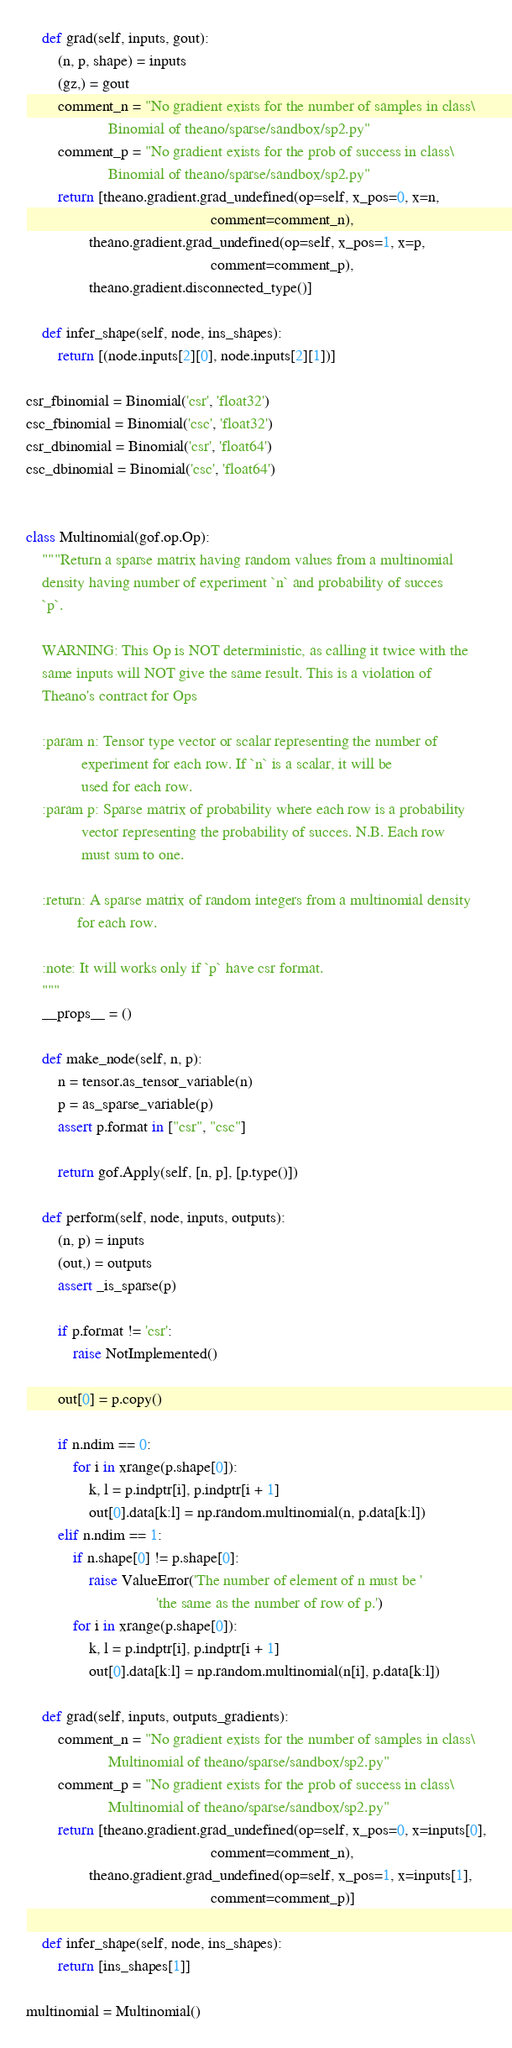Convert code to text. <code><loc_0><loc_0><loc_500><loc_500><_Python_>
    def grad(self, inputs, gout):
        (n, p, shape) = inputs
        (gz,) = gout
        comment_n = "No gradient exists for the number of samples in class\
                     Binomial of theano/sparse/sandbox/sp2.py"
        comment_p = "No gradient exists for the prob of success in class\
                     Binomial of theano/sparse/sandbox/sp2.py"
        return [theano.gradient.grad_undefined(op=self, x_pos=0, x=n,
                                               comment=comment_n),
                theano.gradient.grad_undefined(op=self, x_pos=1, x=p,
                                               comment=comment_p),
                theano.gradient.disconnected_type()]

    def infer_shape(self, node, ins_shapes):
        return [(node.inputs[2][0], node.inputs[2][1])]

csr_fbinomial = Binomial('csr', 'float32')
csc_fbinomial = Binomial('csc', 'float32')
csr_dbinomial = Binomial('csr', 'float64')
csc_dbinomial = Binomial('csc', 'float64')


class Multinomial(gof.op.Op):
    """Return a sparse matrix having random values from a multinomial
    density having number of experiment `n` and probability of succes
    `p`.

    WARNING: This Op is NOT deterministic, as calling it twice with the
    same inputs will NOT give the same result. This is a violation of
    Theano's contract for Ops

    :param n: Tensor type vector or scalar representing the number of
              experiment for each row. If `n` is a scalar, it will be
              used for each row.
    :param p: Sparse matrix of probability where each row is a probability
              vector representing the probability of succes. N.B. Each row
              must sum to one.

    :return: A sparse matrix of random integers from a multinomial density
             for each row.

    :note: It will works only if `p` have csr format.
    """
    __props__ = ()

    def make_node(self, n, p):
        n = tensor.as_tensor_variable(n)
        p = as_sparse_variable(p)
        assert p.format in ["csr", "csc"]

        return gof.Apply(self, [n, p], [p.type()])

    def perform(self, node, inputs, outputs):
        (n, p) = inputs
        (out,) = outputs
        assert _is_sparse(p)

        if p.format != 'csr':
            raise NotImplemented()

        out[0] = p.copy()

        if n.ndim == 0:
            for i in xrange(p.shape[0]):
                k, l = p.indptr[i], p.indptr[i + 1]
                out[0].data[k:l] = np.random.multinomial(n, p.data[k:l])
        elif n.ndim == 1:
            if n.shape[0] != p.shape[0]:
                raise ValueError('The number of element of n must be '
                                 'the same as the number of row of p.')
            for i in xrange(p.shape[0]):
                k, l = p.indptr[i], p.indptr[i + 1]
                out[0].data[k:l] = np.random.multinomial(n[i], p.data[k:l])

    def grad(self, inputs, outputs_gradients):
        comment_n = "No gradient exists for the number of samples in class\
                     Multinomial of theano/sparse/sandbox/sp2.py"
        comment_p = "No gradient exists for the prob of success in class\
                     Multinomial of theano/sparse/sandbox/sp2.py"
        return [theano.gradient.grad_undefined(op=self, x_pos=0, x=inputs[0],
                                               comment=comment_n),
                theano.gradient.grad_undefined(op=self, x_pos=1, x=inputs[1],
                                               comment=comment_p)]

    def infer_shape(self, node, ins_shapes):
        return [ins_shapes[1]]

multinomial = Multinomial()
</code> 